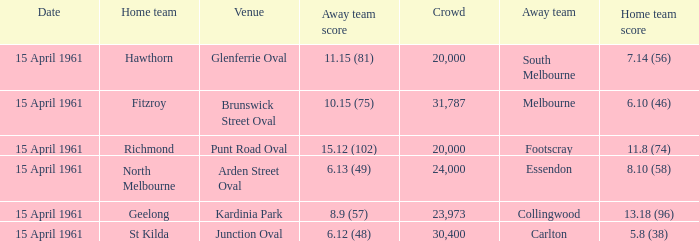What is the average crowd size when Collingwood is the away team? 23973.0. 